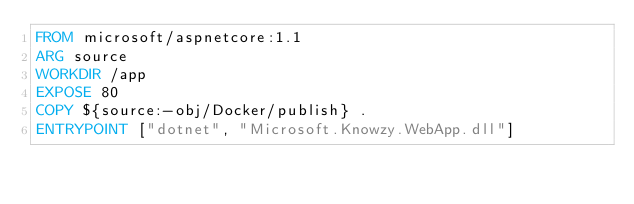Convert code to text. <code><loc_0><loc_0><loc_500><loc_500><_Dockerfile_>FROM microsoft/aspnetcore:1.1
ARG source
WORKDIR /app
EXPOSE 80
COPY ${source:-obj/Docker/publish} .
ENTRYPOINT ["dotnet", "Microsoft.Knowzy.WebApp.dll"]
</code> 